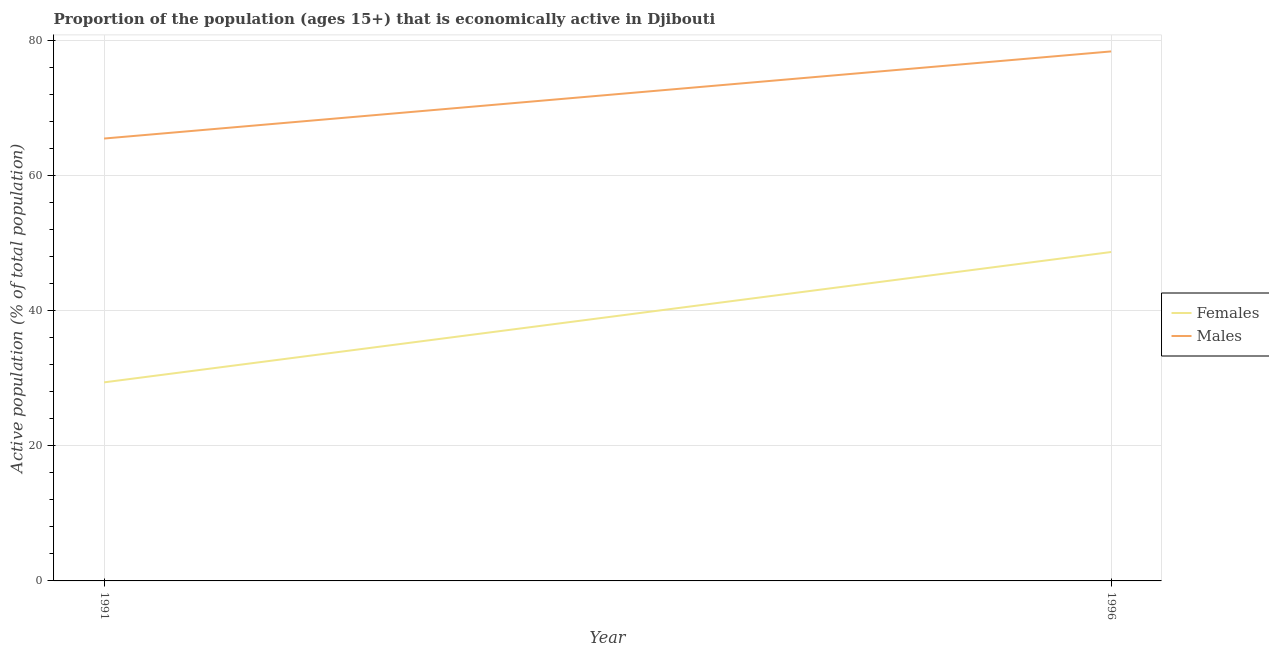Is the number of lines equal to the number of legend labels?
Your response must be concise. Yes. What is the percentage of economically active female population in 1996?
Your response must be concise. 48.7. Across all years, what is the maximum percentage of economically active male population?
Ensure brevity in your answer.  78.4. Across all years, what is the minimum percentage of economically active male population?
Provide a succinct answer. 65.5. In which year was the percentage of economically active male population maximum?
Provide a succinct answer. 1996. What is the total percentage of economically active male population in the graph?
Provide a short and direct response. 143.9. What is the difference between the percentage of economically active female population in 1991 and that in 1996?
Your answer should be compact. -19.3. What is the difference between the percentage of economically active female population in 1991 and the percentage of economically active male population in 1996?
Give a very brief answer. -49. What is the average percentage of economically active female population per year?
Provide a succinct answer. 39.05. In the year 1991, what is the difference between the percentage of economically active male population and percentage of economically active female population?
Offer a very short reply. 36.1. What is the ratio of the percentage of economically active female population in 1991 to that in 1996?
Keep it short and to the point. 0.6. Is the percentage of economically active male population strictly less than the percentage of economically active female population over the years?
Provide a succinct answer. No. How many lines are there?
Ensure brevity in your answer.  2. How many years are there in the graph?
Your answer should be compact. 2. What is the difference between two consecutive major ticks on the Y-axis?
Ensure brevity in your answer.  20. Does the graph contain grids?
Ensure brevity in your answer.  Yes. What is the title of the graph?
Offer a terse response. Proportion of the population (ages 15+) that is economically active in Djibouti. Does "Food and tobacco" appear as one of the legend labels in the graph?
Provide a short and direct response. No. What is the label or title of the Y-axis?
Give a very brief answer. Active population (% of total population). What is the Active population (% of total population) in Females in 1991?
Make the answer very short. 29.4. What is the Active population (% of total population) in Males in 1991?
Your answer should be compact. 65.5. What is the Active population (% of total population) of Females in 1996?
Keep it short and to the point. 48.7. What is the Active population (% of total population) of Males in 1996?
Your answer should be compact. 78.4. Across all years, what is the maximum Active population (% of total population) in Females?
Keep it short and to the point. 48.7. Across all years, what is the maximum Active population (% of total population) of Males?
Offer a terse response. 78.4. Across all years, what is the minimum Active population (% of total population) in Females?
Your answer should be very brief. 29.4. Across all years, what is the minimum Active population (% of total population) in Males?
Your response must be concise. 65.5. What is the total Active population (% of total population) of Females in the graph?
Provide a short and direct response. 78.1. What is the total Active population (% of total population) of Males in the graph?
Offer a very short reply. 143.9. What is the difference between the Active population (% of total population) of Females in 1991 and that in 1996?
Offer a very short reply. -19.3. What is the difference between the Active population (% of total population) in Males in 1991 and that in 1996?
Ensure brevity in your answer.  -12.9. What is the difference between the Active population (% of total population) in Females in 1991 and the Active population (% of total population) in Males in 1996?
Give a very brief answer. -49. What is the average Active population (% of total population) of Females per year?
Ensure brevity in your answer.  39.05. What is the average Active population (% of total population) of Males per year?
Make the answer very short. 71.95. In the year 1991, what is the difference between the Active population (% of total population) in Females and Active population (% of total population) in Males?
Your answer should be very brief. -36.1. In the year 1996, what is the difference between the Active population (% of total population) in Females and Active population (% of total population) in Males?
Provide a short and direct response. -29.7. What is the ratio of the Active population (% of total population) of Females in 1991 to that in 1996?
Keep it short and to the point. 0.6. What is the ratio of the Active population (% of total population) of Males in 1991 to that in 1996?
Make the answer very short. 0.84. What is the difference between the highest and the second highest Active population (% of total population) in Females?
Offer a terse response. 19.3. What is the difference between the highest and the lowest Active population (% of total population) in Females?
Provide a succinct answer. 19.3. What is the difference between the highest and the lowest Active population (% of total population) in Males?
Keep it short and to the point. 12.9. 